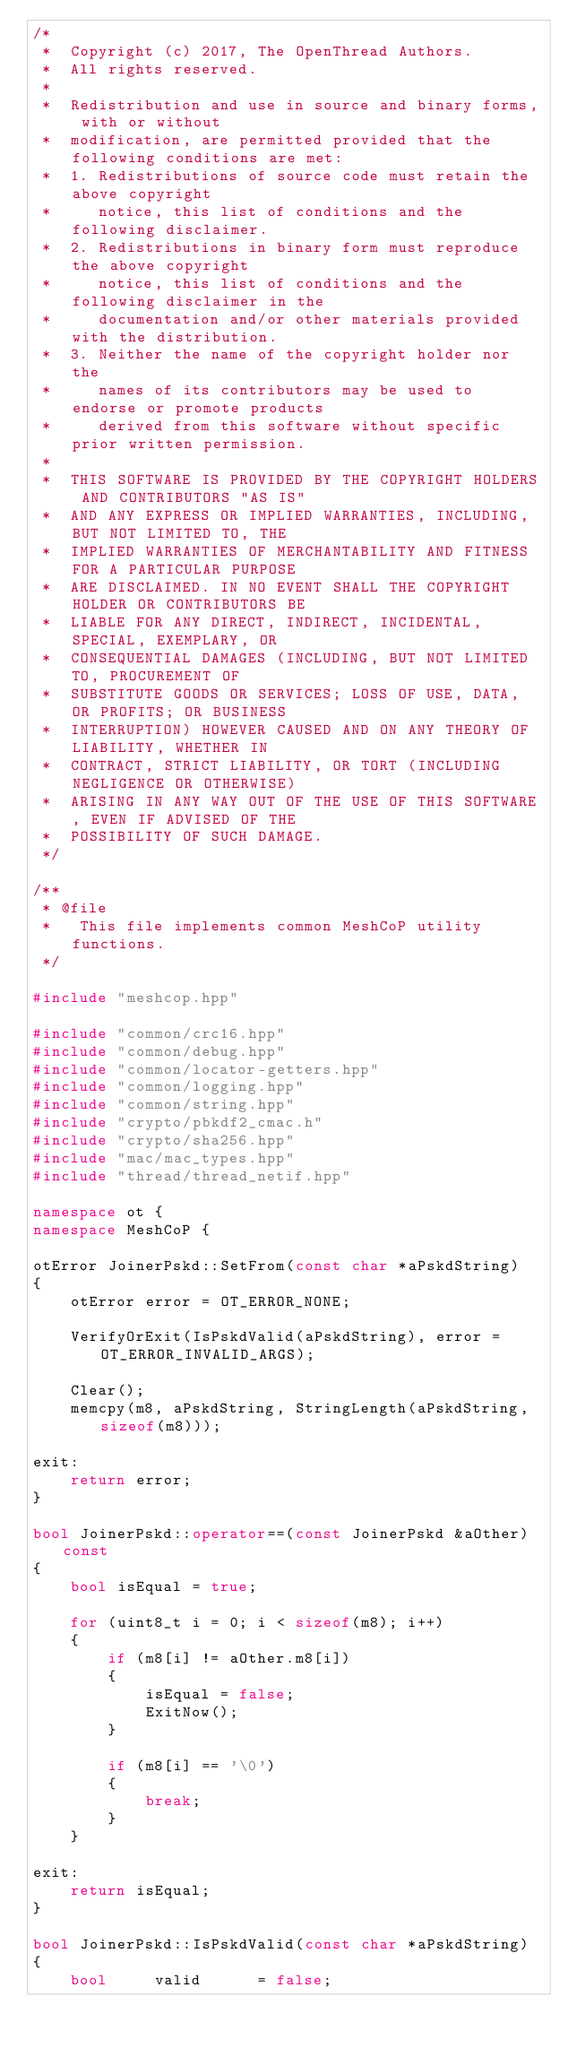<code> <loc_0><loc_0><loc_500><loc_500><_C++_>/*
 *  Copyright (c) 2017, The OpenThread Authors.
 *  All rights reserved.
 *
 *  Redistribution and use in source and binary forms, with or without
 *  modification, are permitted provided that the following conditions are met:
 *  1. Redistributions of source code must retain the above copyright
 *     notice, this list of conditions and the following disclaimer.
 *  2. Redistributions in binary form must reproduce the above copyright
 *     notice, this list of conditions and the following disclaimer in the
 *     documentation and/or other materials provided with the distribution.
 *  3. Neither the name of the copyright holder nor the
 *     names of its contributors may be used to endorse or promote products
 *     derived from this software without specific prior written permission.
 *
 *  THIS SOFTWARE IS PROVIDED BY THE COPYRIGHT HOLDERS AND CONTRIBUTORS "AS IS"
 *  AND ANY EXPRESS OR IMPLIED WARRANTIES, INCLUDING, BUT NOT LIMITED TO, THE
 *  IMPLIED WARRANTIES OF MERCHANTABILITY AND FITNESS FOR A PARTICULAR PURPOSE
 *  ARE DISCLAIMED. IN NO EVENT SHALL THE COPYRIGHT HOLDER OR CONTRIBUTORS BE
 *  LIABLE FOR ANY DIRECT, INDIRECT, INCIDENTAL, SPECIAL, EXEMPLARY, OR
 *  CONSEQUENTIAL DAMAGES (INCLUDING, BUT NOT LIMITED TO, PROCUREMENT OF
 *  SUBSTITUTE GOODS OR SERVICES; LOSS OF USE, DATA, OR PROFITS; OR BUSINESS
 *  INTERRUPTION) HOWEVER CAUSED AND ON ANY THEORY OF LIABILITY, WHETHER IN
 *  CONTRACT, STRICT LIABILITY, OR TORT (INCLUDING NEGLIGENCE OR OTHERWISE)
 *  ARISING IN ANY WAY OUT OF THE USE OF THIS SOFTWARE, EVEN IF ADVISED OF THE
 *  POSSIBILITY OF SUCH DAMAGE.
 */

/**
 * @file
 *   This file implements common MeshCoP utility functions.
 */

#include "meshcop.hpp"

#include "common/crc16.hpp"
#include "common/debug.hpp"
#include "common/locator-getters.hpp"
#include "common/logging.hpp"
#include "common/string.hpp"
#include "crypto/pbkdf2_cmac.h"
#include "crypto/sha256.hpp"
#include "mac/mac_types.hpp"
#include "thread/thread_netif.hpp"

namespace ot {
namespace MeshCoP {

otError JoinerPskd::SetFrom(const char *aPskdString)
{
    otError error = OT_ERROR_NONE;

    VerifyOrExit(IsPskdValid(aPskdString), error = OT_ERROR_INVALID_ARGS);

    Clear();
    memcpy(m8, aPskdString, StringLength(aPskdString, sizeof(m8)));

exit:
    return error;
}

bool JoinerPskd::operator==(const JoinerPskd &aOther) const
{
    bool isEqual = true;

    for (uint8_t i = 0; i < sizeof(m8); i++)
    {
        if (m8[i] != aOther.m8[i])
        {
            isEqual = false;
            ExitNow();
        }

        if (m8[i] == '\0')
        {
            break;
        }
    }

exit:
    return isEqual;
}

bool JoinerPskd::IsPskdValid(const char *aPskdString)
{
    bool     valid      = false;</code> 